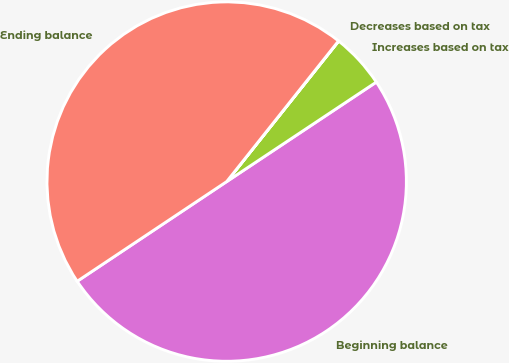Convert chart. <chart><loc_0><loc_0><loc_500><loc_500><pie_chart><fcel>Beginning balance<fcel>Increases based on tax<fcel>Decreases based on tax<fcel>Ending balance<nl><fcel>49.98%<fcel>4.95%<fcel>0.02%<fcel>45.05%<nl></chart> 